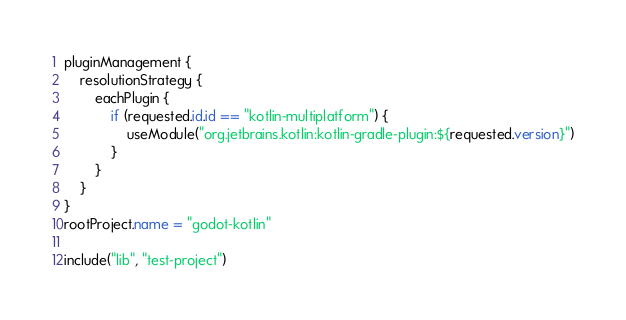<code> <loc_0><loc_0><loc_500><loc_500><_Kotlin_>pluginManagement {
    resolutionStrategy {
        eachPlugin {
            if (requested.id.id == "kotlin-multiplatform") {
                useModule("org.jetbrains.kotlin:kotlin-gradle-plugin:${requested.version}")
            }
        }
    }
}
rootProject.name = "godot-kotlin"

include("lib", "test-project")</code> 